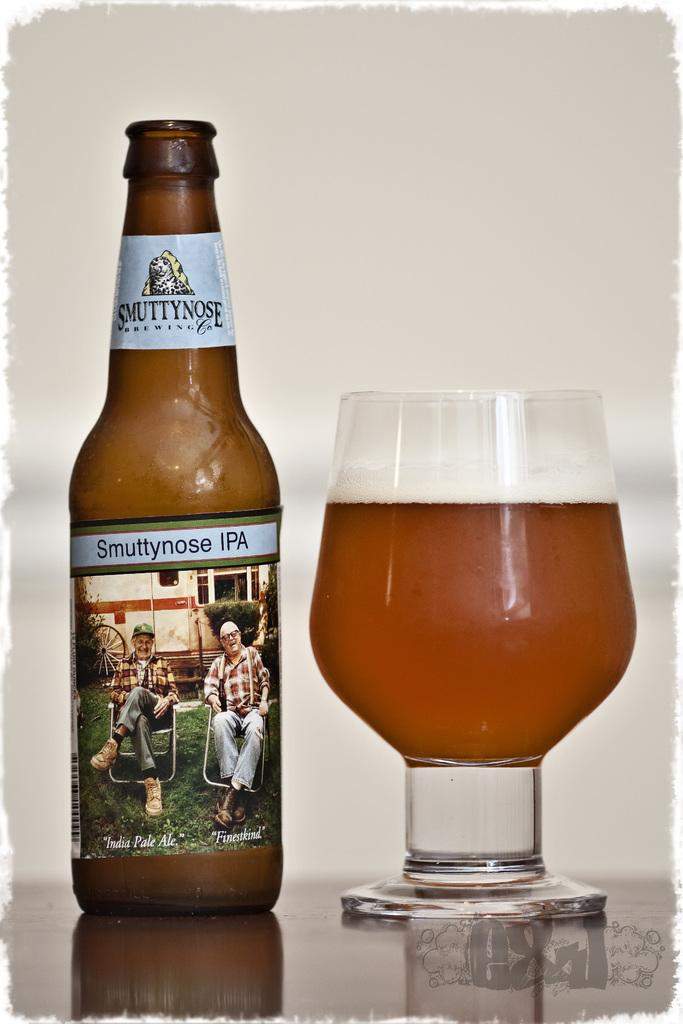<image>
Summarize the visual content of the image. A bottle of Smuttynose IPA is next to a glass that is full. 